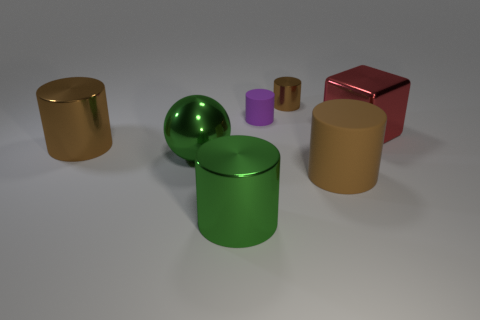Subtract all big cylinders. How many cylinders are left? 2 Subtract all gray cubes. How many brown cylinders are left? 3 Subtract all green cylinders. How many cylinders are left? 4 Subtract all blue cylinders. Subtract all brown blocks. How many cylinders are left? 5 Add 2 small green shiny cylinders. How many objects exist? 9 Subtract all spheres. How many objects are left? 6 Add 3 big green metallic balls. How many big green metallic balls are left? 4 Add 5 purple cylinders. How many purple cylinders exist? 6 Subtract 0 brown blocks. How many objects are left? 7 Subtract all large gray rubber things. Subtract all big green metallic cylinders. How many objects are left? 6 